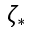<formula> <loc_0><loc_0><loc_500><loc_500>\zeta _ { * }</formula> 